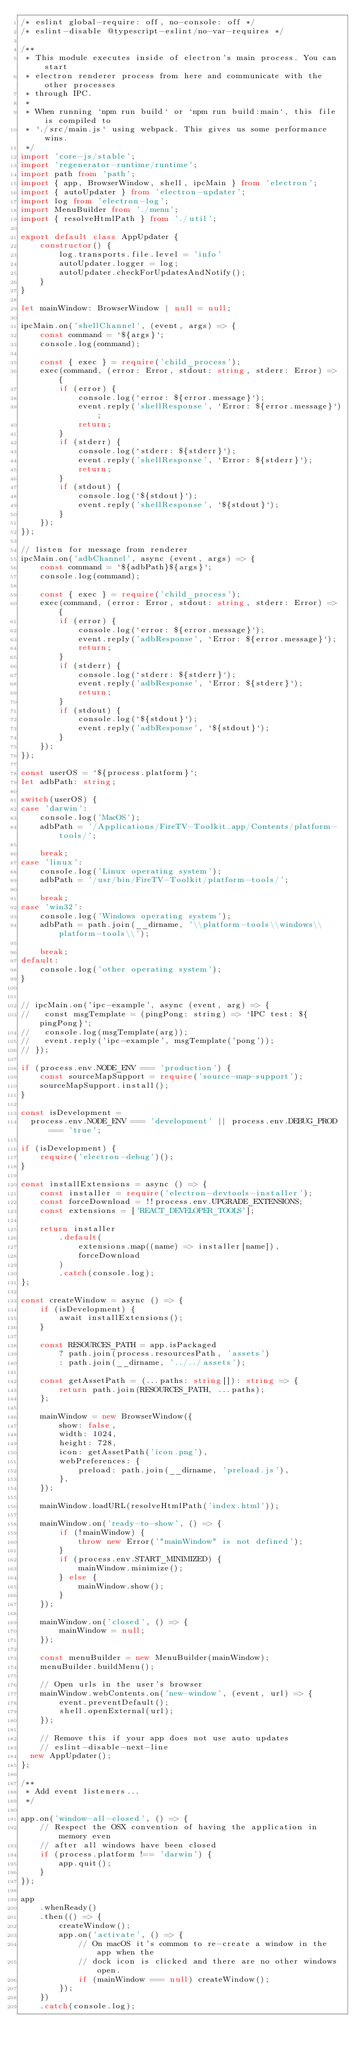<code> <loc_0><loc_0><loc_500><loc_500><_TypeScript_>/* eslint global-require: off, no-console: off */
/* eslint-disable @typescript-eslint/no-var-requires */

/**
 * This module executes inside of electron's main process. You can start
 * electron renderer process from here and communicate with the other processes
 * through IPC.
 *
 * When running `npm run build` or `npm run build:main`, this file is compiled to
 * `./src/main.js` using webpack. This gives us some performance wins.
 */
import 'core-js/stable';
import 'regenerator-runtime/runtime';
import path from 'path';
import { app, BrowserWindow, shell, ipcMain } from 'electron';
import { autoUpdater } from 'electron-updater';
import log from 'electron-log';
import MenuBuilder from './menu';
import { resolveHtmlPath } from './util';

export default class AppUpdater {
    constructor() {
        log.transports.file.level = 'info'
        autoUpdater.logger = log;
        autoUpdater.checkForUpdatesAndNotify();
    }
}

let mainWindow: BrowserWindow | null = null;

ipcMain.on('shellChannel', (event, args) => {
    const command = `${args}`;
    console.log(command);

    const { exec } = require('child_process');
    exec(command, (error: Error, stdout: string, stderr: Error) => {
        if (error) {
            console.log(`error: ${error.message}`);
            event.reply('shellResponse', `Error: ${error.message}`);
            return;
        }
        if (stderr) {
            console.log(`stderr: ${stderr}`);
            event.reply('shellResponse', `Error: ${stderr}`);
            return;
        }
        if (stdout) {
            console.log(`${stdout}`);
            event.reply('shellResponse', `${stdout}`);
        }
    });
});

// listen for message from renderer
ipcMain.on('adbChannel', async (event, args) => {
    const command = `${adbPath}${args}`;
    console.log(command);

    const { exec } = require('child_process');
    exec(command, (error: Error, stdout: string, stderr: Error) => {
        if (error) {
            console.log(`error: ${error.message}`);
            event.reply('adbResponse', `Error: ${error.message}`);
            return;
        }
        if (stderr) {
            console.log(`stderr: ${stderr}`);
            event.reply('adbResponse', `Error: ${stderr}`);
            return;
        }
        if (stdout) {
            console.log(`${stdout}`);
            event.reply('adbResponse', `${stdout}`);
        }
    });
});

const userOS = `${process.platform}`;
let adbPath: string;

switch(userOS) {
case 'darwin':
    console.log('MacOS');
    adbPath = '/Applications/FireTV-Toolkit.app/Contents/platform-tools/';

    break;
case 'linux':
    console.log('Linux operating system');
    adbPath = '/usr/bin/FireTV-Toolkit/platform-tools/';

    break;
case 'win32':
    console.log('Windows operating system');
    adbPath = path.join(__dirname, '\\platform-tools\\windows\\platform-tools\\');

    break;
default:
    console.log('other operating system');
}


// ipcMain.on('ipc-example', async (event, arg) => {
//   const msgTemplate = (pingPong: string) => `IPC test: ${pingPong}`;
//   console.log(msgTemplate(arg));
//   event.reply('ipc-example', msgTemplate('pong'));
// });

if (process.env.NODE_ENV === 'production') {
    const sourceMapSupport = require('source-map-support');
    sourceMapSupport.install();
}

const isDevelopment =
  process.env.NODE_ENV === 'development' || process.env.DEBUG_PROD === 'true';

if (isDevelopment) {
    require('electron-debug')();
}

const installExtensions = async () => {
    const installer = require('electron-devtools-installer');
    const forceDownload = !!process.env.UPGRADE_EXTENSIONS;
    const extensions = ['REACT_DEVELOPER_TOOLS'];

    return installer
        .default(
            extensions.map((name) => installer[name]),
            forceDownload
        )
        .catch(console.log);
};

const createWindow = async () => {
    if (isDevelopment) {
        await installExtensions();
    }

    const RESOURCES_PATH = app.isPackaged
        ? path.join(process.resourcesPath, 'assets')
        : path.join(__dirname, '../../assets');

    const getAssetPath = (...paths: string[]): string => {
        return path.join(RESOURCES_PATH, ...paths);
    };

    mainWindow = new BrowserWindow({
        show: false,
        width: 1024,
        height: 728,
        icon: getAssetPath('icon.png'),
        webPreferences: {
            preload: path.join(__dirname, 'preload.js'),
        },
    });

    mainWindow.loadURL(resolveHtmlPath('index.html'));

    mainWindow.on('ready-to-show', () => {
        if (!mainWindow) {
            throw new Error('"mainWindow" is not defined');
        }
        if (process.env.START_MINIMIZED) {
            mainWindow.minimize();
        } else {
            mainWindow.show();
        }
    });

    mainWindow.on('closed', () => {
        mainWindow = null;
    });

    const menuBuilder = new MenuBuilder(mainWindow);
    menuBuilder.buildMenu();

    // Open urls in the user's browser
    mainWindow.webContents.on('new-window', (event, url) => {
        event.preventDefault();
        shell.openExternal(url);
    });

    // Remove this if your app does not use auto updates
    // eslint-disable-next-line
  new AppUpdater();
};

/**
 * Add event listeners...
 */

app.on('window-all-closed', () => {
    // Respect the OSX convention of having the application in memory even
    // after all windows have been closed
    if (process.platform !== 'darwin') {
        app.quit();
    }
});

app
    .whenReady()
    .then(() => {
        createWindow();
        app.on('activate', () => {
            // On macOS it's common to re-create a window in the app when the
            // dock icon is clicked and there are no other windows open.
            if (mainWindow === null) createWindow();
        });
    })
    .catch(console.log);
</code> 